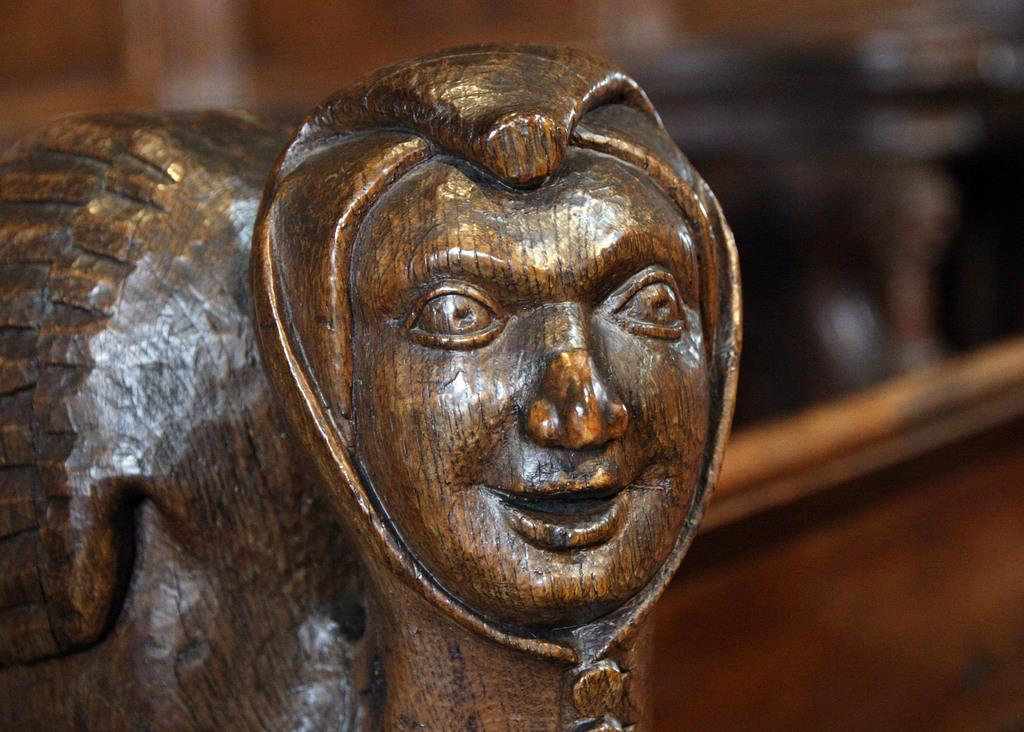What is the main subject of the image? There is a sculpture in the image. Can you describe the background of the image? The background of the image is blurred. Can you see a match being lit in the image? There is no match or any indication of fire in the image; it features a sculpture and a blurred background. 